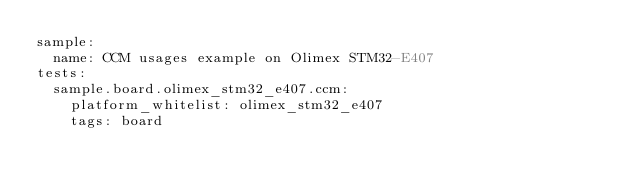Convert code to text. <code><loc_0><loc_0><loc_500><loc_500><_YAML_>sample:
  name: CCM usages example on Olimex STM32-E407
tests:
  sample.board.olimex_stm32_e407.ccm:
    platform_whitelist: olimex_stm32_e407
    tags: board

</code> 